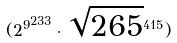Convert formula to latex. <formula><loc_0><loc_0><loc_500><loc_500>( { 2 ^ { 9 } } ^ { 2 3 3 } \cdot \sqrt { 2 6 5 } ^ { 4 1 5 } )</formula> 